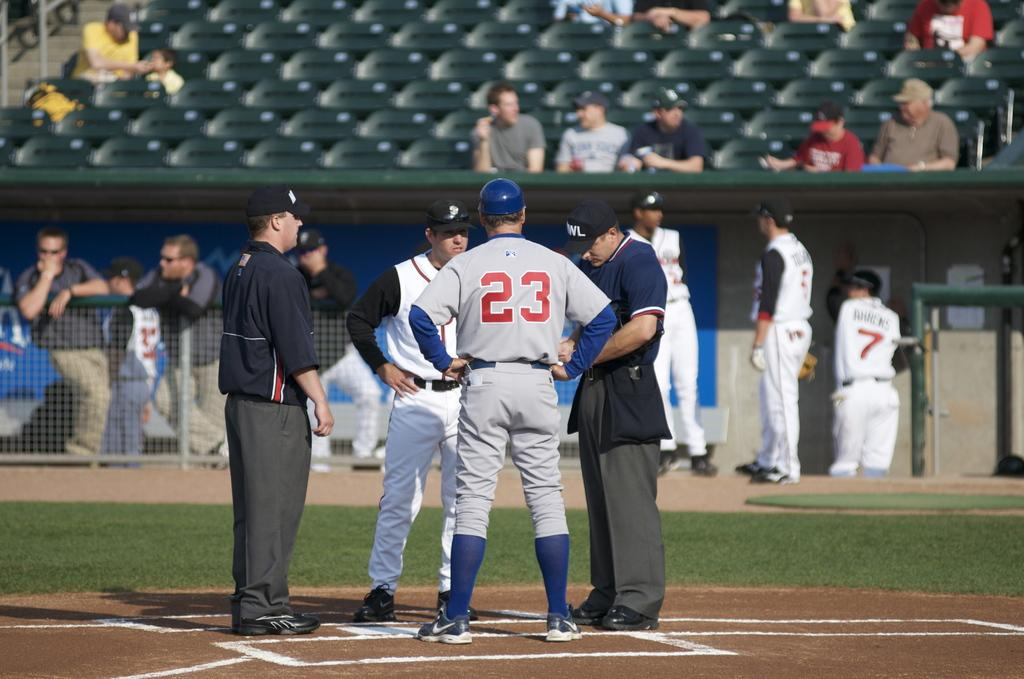<image>
Create a compact narrative representing the image presented. a person that has a number on their jersey which is 23 